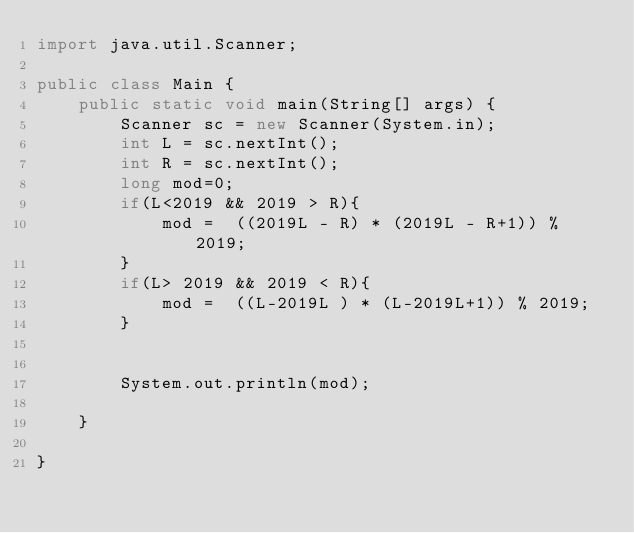Convert code to text. <code><loc_0><loc_0><loc_500><loc_500><_Java_>import java.util.Scanner;

public class Main {
    public static void main(String[] args) {
        Scanner sc = new Scanner(System.in);
        int L = sc.nextInt();
        int R = sc.nextInt();
        long mod=0;
        if(L<2019 && 2019 > R){
            mod =  ((2019L - R) * (2019L - R+1)) % 2019;
        }
        if(L> 2019 && 2019 < R){
            mod =  ((L-2019L ) * (L-2019L+1)) % 2019;
        }


        System.out.println(mod);

    }

}
</code> 